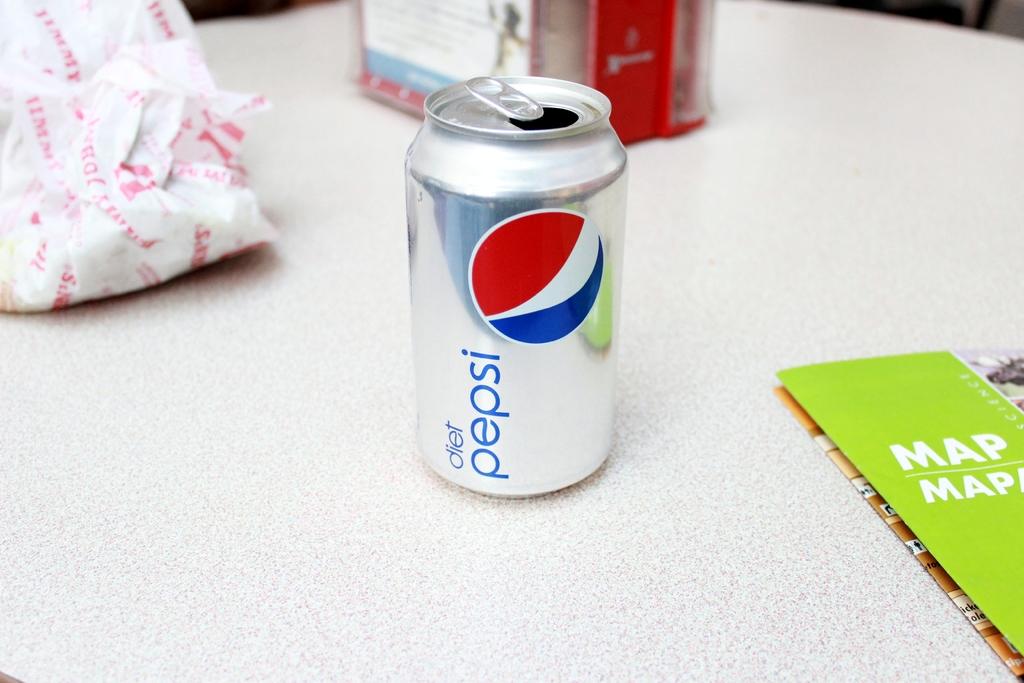What kind of pamplet is it?
Make the answer very short. Map. 